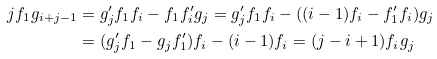Convert formula to latex. <formula><loc_0><loc_0><loc_500><loc_500>j f _ { 1 } g _ { i + j - 1 } & = g ^ { \prime } _ { j } f _ { 1 } f _ { i } - f _ { 1 } f ^ { \prime } _ { i } g _ { j } = g ^ { \prime } _ { j } f _ { 1 } f _ { i } - ( ( i - 1 ) f _ { i } - f ^ { \prime } _ { 1 } f _ { i } ) g _ { j } \\ & = ( g ^ { \prime } _ { j } f _ { 1 } - g _ { j } f ^ { \prime } _ { 1 } ) f _ { i } - ( i - 1 ) f _ { i } = ( j - i + 1 ) f _ { i } g _ { j }</formula> 